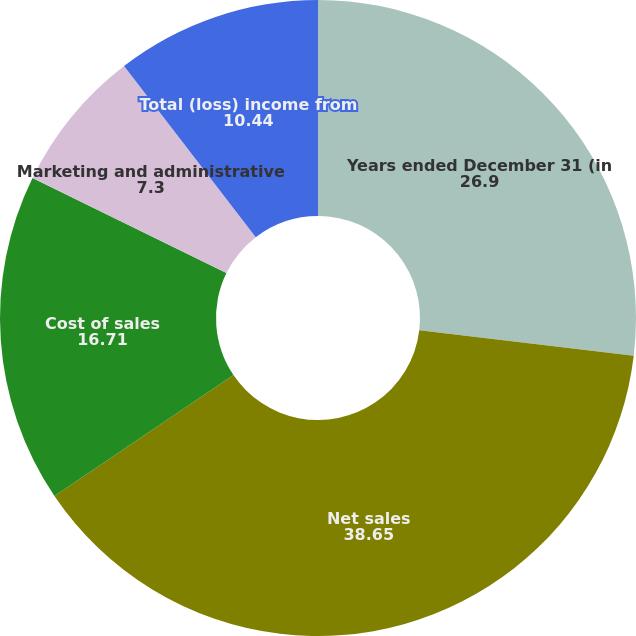<chart> <loc_0><loc_0><loc_500><loc_500><pie_chart><fcel>Years ended December 31 (in<fcel>Net sales<fcel>Cost of sales<fcel>Marketing and administrative<fcel>Total (loss) income from<nl><fcel>26.9%<fcel>38.65%<fcel>16.71%<fcel>7.3%<fcel>10.44%<nl></chart> 